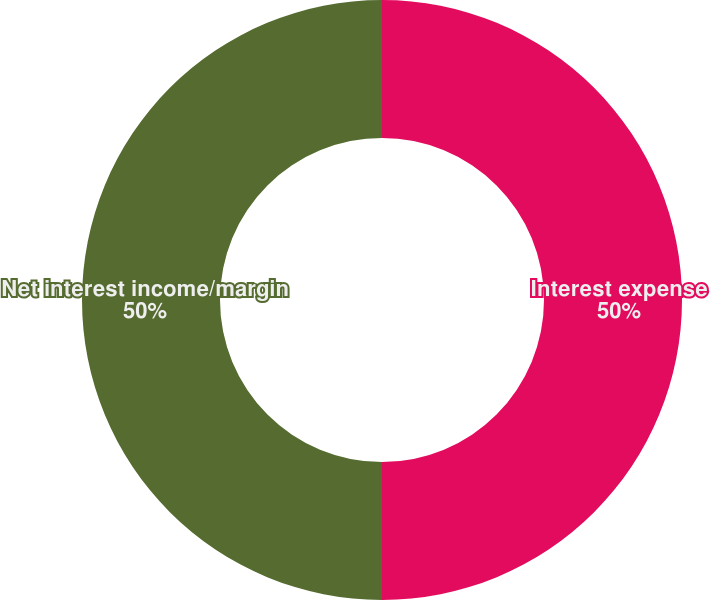Convert chart to OTSL. <chart><loc_0><loc_0><loc_500><loc_500><pie_chart><fcel>Interest expense<fcel>Net interest income/margin<nl><fcel>50.0%<fcel>50.0%<nl></chart> 